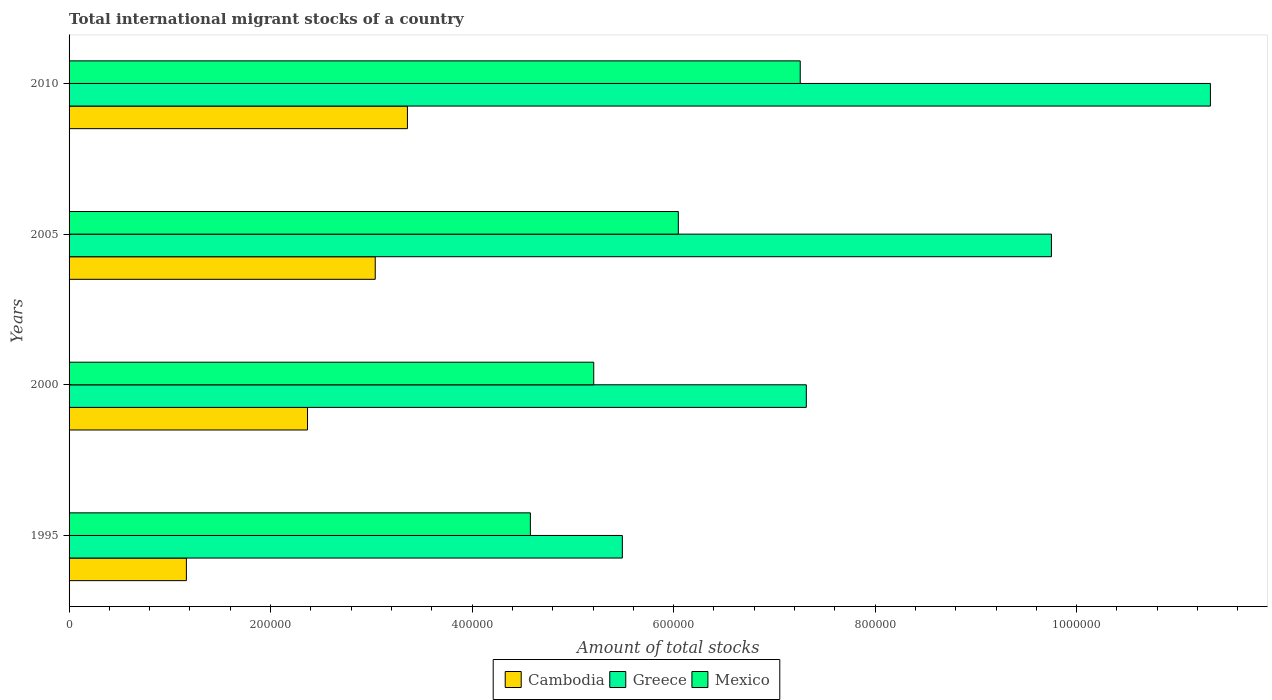How many different coloured bars are there?
Make the answer very short. 3. Are the number of bars per tick equal to the number of legend labels?
Your answer should be very brief. Yes. How many bars are there on the 1st tick from the top?
Provide a succinct answer. 3. What is the amount of total stocks in in Greece in 2000?
Offer a very short reply. 7.32e+05. Across all years, what is the maximum amount of total stocks in in Cambodia?
Make the answer very short. 3.36e+05. Across all years, what is the minimum amount of total stocks in in Cambodia?
Offer a very short reply. 1.16e+05. In which year was the amount of total stocks in in Greece minimum?
Make the answer very short. 1995. What is the total amount of total stocks in in Greece in the graph?
Your response must be concise. 3.39e+06. What is the difference between the amount of total stocks in in Cambodia in 2005 and that in 2010?
Your answer should be compact. -3.20e+04. What is the difference between the amount of total stocks in in Mexico in 2005 and the amount of total stocks in in Cambodia in 1995?
Keep it short and to the point. 4.88e+05. What is the average amount of total stocks in in Greece per year?
Make the answer very short. 8.47e+05. In the year 2010, what is the difference between the amount of total stocks in in Cambodia and amount of total stocks in in Greece?
Offer a terse response. -7.97e+05. In how many years, is the amount of total stocks in in Cambodia greater than 560000 ?
Your answer should be compact. 0. What is the ratio of the amount of total stocks in in Mexico in 1995 to that in 2005?
Provide a succinct answer. 0.76. Is the amount of total stocks in in Greece in 1995 less than that in 2010?
Give a very brief answer. Yes. What is the difference between the highest and the second highest amount of total stocks in in Greece?
Provide a short and direct response. 1.58e+05. What is the difference between the highest and the lowest amount of total stocks in in Cambodia?
Your response must be concise. 2.19e+05. What does the 1st bar from the bottom in 2010 represents?
Ensure brevity in your answer.  Cambodia. How many bars are there?
Offer a terse response. 12. How many years are there in the graph?
Keep it short and to the point. 4. What is the difference between two consecutive major ticks on the X-axis?
Ensure brevity in your answer.  2.00e+05. Does the graph contain any zero values?
Make the answer very short. No. Does the graph contain grids?
Provide a succinct answer. No. Where does the legend appear in the graph?
Offer a very short reply. Bottom center. How many legend labels are there?
Keep it short and to the point. 3. What is the title of the graph?
Provide a succinct answer. Total international migrant stocks of a country. What is the label or title of the X-axis?
Your answer should be compact. Amount of total stocks. What is the Amount of total stocks in Cambodia in 1995?
Your answer should be very brief. 1.16e+05. What is the Amount of total stocks of Greece in 1995?
Your answer should be very brief. 5.49e+05. What is the Amount of total stocks in Mexico in 1995?
Ensure brevity in your answer.  4.58e+05. What is the Amount of total stocks in Cambodia in 2000?
Make the answer very short. 2.37e+05. What is the Amount of total stocks of Greece in 2000?
Provide a short and direct response. 7.32e+05. What is the Amount of total stocks of Mexico in 2000?
Give a very brief answer. 5.21e+05. What is the Amount of total stocks in Cambodia in 2005?
Keep it short and to the point. 3.04e+05. What is the Amount of total stocks in Greece in 2005?
Offer a very short reply. 9.75e+05. What is the Amount of total stocks of Mexico in 2005?
Provide a short and direct response. 6.05e+05. What is the Amount of total stocks of Cambodia in 2010?
Keep it short and to the point. 3.36e+05. What is the Amount of total stocks of Greece in 2010?
Your answer should be compact. 1.13e+06. What is the Amount of total stocks in Mexico in 2010?
Offer a terse response. 7.26e+05. Across all years, what is the maximum Amount of total stocks of Cambodia?
Keep it short and to the point. 3.36e+05. Across all years, what is the maximum Amount of total stocks of Greece?
Keep it short and to the point. 1.13e+06. Across all years, what is the maximum Amount of total stocks of Mexico?
Give a very brief answer. 7.26e+05. Across all years, what is the minimum Amount of total stocks of Cambodia?
Offer a very short reply. 1.16e+05. Across all years, what is the minimum Amount of total stocks in Greece?
Your answer should be very brief. 5.49e+05. Across all years, what is the minimum Amount of total stocks of Mexico?
Ensure brevity in your answer.  4.58e+05. What is the total Amount of total stocks of Cambodia in the graph?
Keep it short and to the point. 9.93e+05. What is the total Amount of total stocks of Greece in the graph?
Make the answer very short. 3.39e+06. What is the total Amount of total stocks in Mexico in the graph?
Provide a short and direct response. 2.31e+06. What is the difference between the Amount of total stocks in Cambodia in 1995 and that in 2000?
Your response must be concise. -1.20e+05. What is the difference between the Amount of total stocks in Greece in 1995 and that in 2000?
Offer a very short reply. -1.83e+05. What is the difference between the Amount of total stocks of Mexico in 1995 and that in 2000?
Your answer should be very brief. -6.29e+04. What is the difference between the Amount of total stocks of Cambodia in 1995 and that in 2005?
Give a very brief answer. -1.87e+05. What is the difference between the Amount of total stocks of Greece in 1995 and that in 2005?
Keep it short and to the point. -4.26e+05. What is the difference between the Amount of total stocks in Mexico in 1995 and that in 2005?
Offer a very short reply. -1.47e+05. What is the difference between the Amount of total stocks of Cambodia in 1995 and that in 2010?
Provide a succinct answer. -2.19e+05. What is the difference between the Amount of total stocks of Greece in 1995 and that in 2010?
Your response must be concise. -5.84e+05. What is the difference between the Amount of total stocks in Mexico in 1995 and that in 2010?
Offer a very short reply. -2.68e+05. What is the difference between the Amount of total stocks in Cambodia in 2000 and that in 2005?
Provide a short and direct response. -6.72e+04. What is the difference between the Amount of total stocks in Greece in 2000 and that in 2005?
Your answer should be compact. -2.43e+05. What is the difference between the Amount of total stocks in Mexico in 2000 and that in 2005?
Ensure brevity in your answer.  -8.39e+04. What is the difference between the Amount of total stocks of Cambodia in 2000 and that in 2010?
Your answer should be very brief. -9.92e+04. What is the difference between the Amount of total stocks in Greece in 2000 and that in 2010?
Give a very brief answer. -4.01e+05. What is the difference between the Amount of total stocks of Mexico in 2000 and that in 2010?
Keep it short and to the point. -2.05e+05. What is the difference between the Amount of total stocks in Cambodia in 2005 and that in 2010?
Offer a terse response. -3.20e+04. What is the difference between the Amount of total stocks in Greece in 2005 and that in 2010?
Your answer should be very brief. -1.58e+05. What is the difference between the Amount of total stocks of Mexico in 2005 and that in 2010?
Provide a short and direct response. -1.21e+05. What is the difference between the Amount of total stocks in Cambodia in 1995 and the Amount of total stocks in Greece in 2000?
Provide a succinct answer. -6.15e+05. What is the difference between the Amount of total stocks of Cambodia in 1995 and the Amount of total stocks of Mexico in 2000?
Provide a short and direct response. -4.04e+05. What is the difference between the Amount of total stocks of Greece in 1995 and the Amount of total stocks of Mexico in 2000?
Provide a short and direct response. 2.84e+04. What is the difference between the Amount of total stocks of Cambodia in 1995 and the Amount of total stocks of Greece in 2005?
Make the answer very short. -8.59e+05. What is the difference between the Amount of total stocks of Cambodia in 1995 and the Amount of total stocks of Mexico in 2005?
Provide a succinct answer. -4.88e+05. What is the difference between the Amount of total stocks in Greece in 1995 and the Amount of total stocks in Mexico in 2005?
Offer a terse response. -5.56e+04. What is the difference between the Amount of total stocks in Cambodia in 1995 and the Amount of total stocks in Greece in 2010?
Your answer should be very brief. -1.02e+06. What is the difference between the Amount of total stocks of Cambodia in 1995 and the Amount of total stocks of Mexico in 2010?
Your answer should be very brief. -6.09e+05. What is the difference between the Amount of total stocks of Greece in 1995 and the Amount of total stocks of Mexico in 2010?
Ensure brevity in your answer.  -1.77e+05. What is the difference between the Amount of total stocks in Cambodia in 2000 and the Amount of total stocks in Greece in 2005?
Keep it short and to the point. -7.38e+05. What is the difference between the Amount of total stocks of Cambodia in 2000 and the Amount of total stocks of Mexico in 2005?
Offer a very short reply. -3.68e+05. What is the difference between the Amount of total stocks of Greece in 2000 and the Amount of total stocks of Mexico in 2005?
Provide a succinct answer. 1.27e+05. What is the difference between the Amount of total stocks in Cambodia in 2000 and the Amount of total stocks in Greece in 2010?
Offer a terse response. -8.96e+05. What is the difference between the Amount of total stocks of Cambodia in 2000 and the Amount of total stocks of Mexico in 2010?
Ensure brevity in your answer.  -4.89e+05. What is the difference between the Amount of total stocks of Greece in 2000 and the Amount of total stocks of Mexico in 2010?
Offer a very short reply. 6022. What is the difference between the Amount of total stocks of Cambodia in 2005 and the Amount of total stocks of Greece in 2010?
Give a very brief answer. -8.29e+05. What is the difference between the Amount of total stocks of Cambodia in 2005 and the Amount of total stocks of Mexico in 2010?
Offer a terse response. -4.22e+05. What is the difference between the Amount of total stocks of Greece in 2005 and the Amount of total stocks of Mexico in 2010?
Offer a terse response. 2.49e+05. What is the average Amount of total stocks in Cambodia per year?
Make the answer very short. 2.48e+05. What is the average Amount of total stocks of Greece per year?
Your response must be concise. 8.47e+05. What is the average Amount of total stocks in Mexico per year?
Provide a short and direct response. 5.77e+05. In the year 1995, what is the difference between the Amount of total stocks of Cambodia and Amount of total stocks of Greece?
Provide a succinct answer. -4.33e+05. In the year 1995, what is the difference between the Amount of total stocks in Cambodia and Amount of total stocks in Mexico?
Offer a very short reply. -3.41e+05. In the year 1995, what is the difference between the Amount of total stocks in Greece and Amount of total stocks in Mexico?
Keep it short and to the point. 9.13e+04. In the year 2000, what is the difference between the Amount of total stocks of Cambodia and Amount of total stocks of Greece?
Give a very brief answer. -4.95e+05. In the year 2000, what is the difference between the Amount of total stocks of Cambodia and Amount of total stocks of Mexico?
Provide a short and direct response. -2.84e+05. In the year 2000, what is the difference between the Amount of total stocks in Greece and Amount of total stocks in Mexico?
Make the answer very short. 2.11e+05. In the year 2005, what is the difference between the Amount of total stocks in Cambodia and Amount of total stocks in Greece?
Your answer should be compact. -6.71e+05. In the year 2005, what is the difference between the Amount of total stocks in Cambodia and Amount of total stocks in Mexico?
Keep it short and to the point. -3.01e+05. In the year 2005, what is the difference between the Amount of total stocks of Greece and Amount of total stocks of Mexico?
Provide a succinct answer. 3.70e+05. In the year 2010, what is the difference between the Amount of total stocks of Cambodia and Amount of total stocks of Greece?
Your answer should be compact. -7.97e+05. In the year 2010, what is the difference between the Amount of total stocks in Cambodia and Amount of total stocks in Mexico?
Your answer should be very brief. -3.90e+05. In the year 2010, what is the difference between the Amount of total stocks of Greece and Amount of total stocks of Mexico?
Your answer should be compact. 4.07e+05. What is the ratio of the Amount of total stocks of Cambodia in 1995 to that in 2000?
Provide a short and direct response. 0.49. What is the ratio of the Amount of total stocks in Greece in 1995 to that in 2000?
Offer a terse response. 0.75. What is the ratio of the Amount of total stocks of Mexico in 1995 to that in 2000?
Offer a very short reply. 0.88. What is the ratio of the Amount of total stocks in Cambodia in 1995 to that in 2005?
Give a very brief answer. 0.38. What is the ratio of the Amount of total stocks in Greece in 1995 to that in 2005?
Your answer should be compact. 0.56. What is the ratio of the Amount of total stocks in Mexico in 1995 to that in 2005?
Your answer should be very brief. 0.76. What is the ratio of the Amount of total stocks of Cambodia in 1995 to that in 2010?
Ensure brevity in your answer.  0.35. What is the ratio of the Amount of total stocks of Greece in 1995 to that in 2010?
Make the answer very short. 0.48. What is the ratio of the Amount of total stocks in Mexico in 1995 to that in 2010?
Keep it short and to the point. 0.63. What is the ratio of the Amount of total stocks in Cambodia in 2000 to that in 2005?
Give a very brief answer. 0.78. What is the ratio of the Amount of total stocks in Greece in 2000 to that in 2005?
Offer a terse response. 0.75. What is the ratio of the Amount of total stocks in Mexico in 2000 to that in 2005?
Offer a very short reply. 0.86. What is the ratio of the Amount of total stocks of Cambodia in 2000 to that in 2010?
Give a very brief answer. 0.7. What is the ratio of the Amount of total stocks in Greece in 2000 to that in 2010?
Provide a succinct answer. 0.65. What is the ratio of the Amount of total stocks in Mexico in 2000 to that in 2010?
Your answer should be very brief. 0.72. What is the ratio of the Amount of total stocks of Cambodia in 2005 to that in 2010?
Make the answer very short. 0.9. What is the ratio of the Amount of total stocks in Greece in 2005 to that in 2010?
Give a very brief answer. 0.86. What is the ratio of the Amount of total stocks in Mexico in 2005 to that in 2010?
Make the answer very short. 0.83. What is the difference between the highest and the second highest Amount of total stocks in Cambodia?
Provide a succinct answer. 3.20e+04. What is the difference between the highest and the second highest Amount of total stocks in Greece?
Ensure brevity in your answer.  1.58e+05. What is the difference between the highest and the second highest Amount of total stocks of Mexico?
Your response must be concise. 1.21e+05. What is the difference between the highest and the lowest Amount of total stocks of Cambodia?
Offer a very short reply. 2.19e+05. What is the difference between the highest and the lowest Amount of total stocks in Greece?
Your answer should be compact. 5.84e+05. What is the difference between the highest and the lowest Amount of total stocks of Mexico?
Provide a succinct answer. 2.68e+05. 